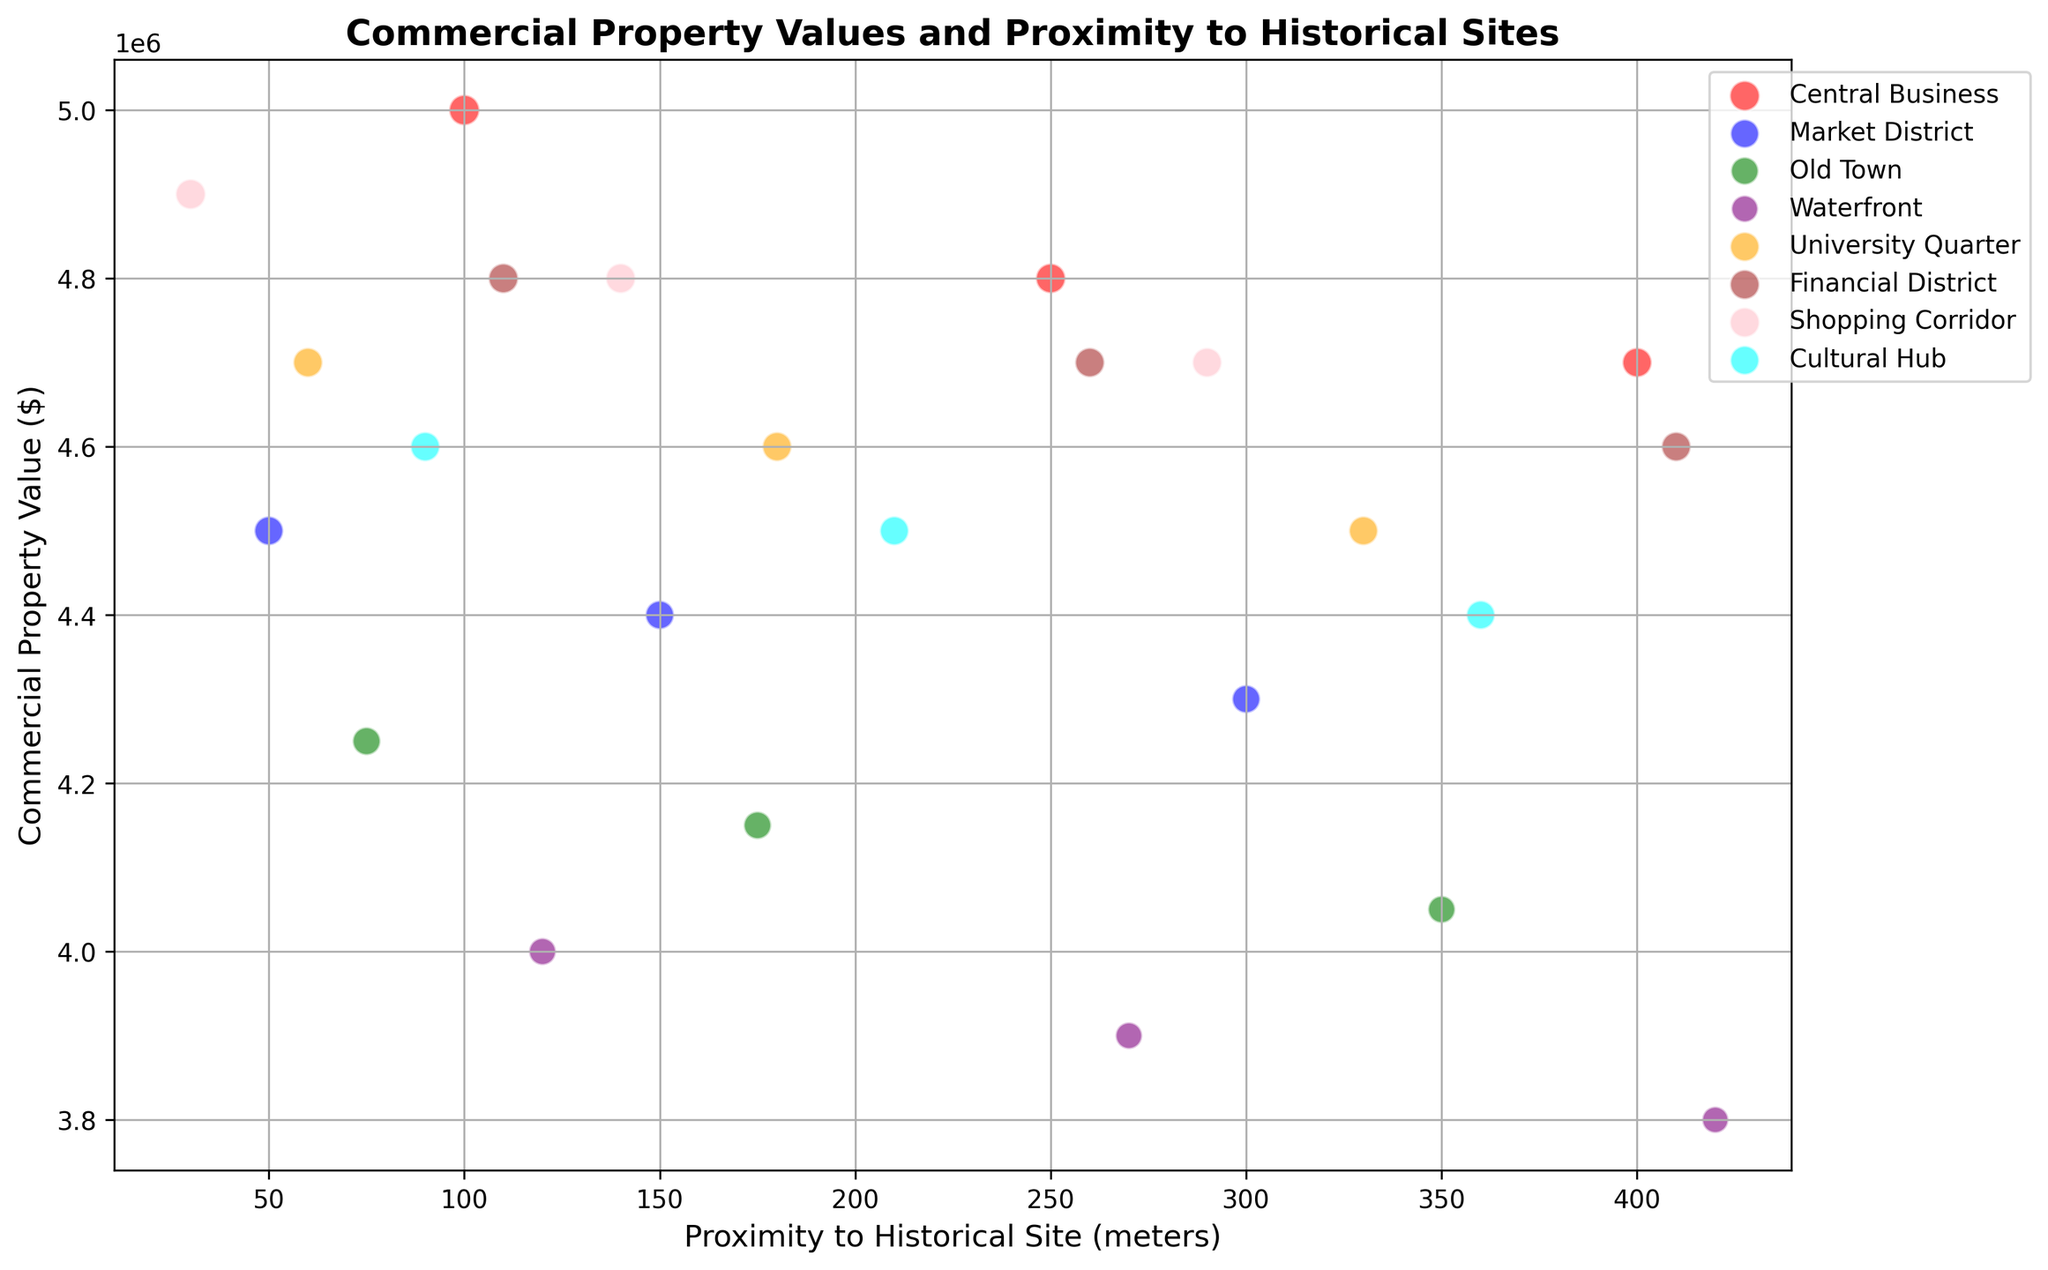Which district has the highest commercial property value nearest to a historical site? Scan visually for the bubble with the highest y-axis value which is closest to the y-axis based on x-axis values. The Shopping Corridor at 30 meters has the highest property value of $4,900,000.
Answer: Shopping Corridor Which district shows the least difference in commercial property value between 100 meters and 250 meters proximity to historical sites? Calculate the change in property value for each district between these proximities. For Central Business, the difference is $5,000,000 - $4,800,000 = $200,000, which is the smallest change.
Answer: Central Business In the Old Town district, what is the average commercial property value within 200 meters of a historical site? Calculate the average value of properties at 75 meters and 175 meters: ($4,250,000 + $4,150,000)/2 = $4,200,000.
Answer: $4,200,000 Which district shows the greatest decrease in commercial property value as proximity to a historical site increases from 50 meters to 300 meters? Identify the changes in property values for each district and compare: Market District's property values drop from $4,500,000 to $4,300,000, a decrease of $200,000.
Answer: Market District What is the proximity to historical sites of the bubbles in the Cultural Hub that display the smallest commercial property values? Scan the properties in the Cultural Hub district and identify the smallest value at $4,400,000, which corresponds to 360 meters.
Answer: 360 meters Which district has the most significant bubble size for properties over $4.8 million? Look for the largest bubbles above $4.8 million. The Central Business and Shopping Corridor both have large bubbles, but Shopping Corridor's is slightly larger at 100.
Answer: Shopping Corridor What is the typical commercial property value trend in the Financial District as proximity to a historical site increases? Observe the general pattern of bubbles from 110 meters to 410 meters. The values decrease progressively from $4,800,000 to $4,600,000.
Answer: Decreasing Compare the commercial property value trends between Shopping Corridor and Market District. Which one shows a steeper decline as the distance from historical sites increases? Compare the changes: Shopping Corridor values drop from $4,900,000 to $4,700,000, a decrease of $200,000. Market District shows a decrease from $4,500,000 to $4,300,000, a steeper decrease of $200,000.
Answer: Market District Which district exhibits property values that consistently trail behind others across all proximities to historical sites? Look at the trends for each district and observe the one consistently lower than the others. The Waterfront’s values range between $4,000,000 and $3,800,000, trailing behind others.
Answer: Waterfront 